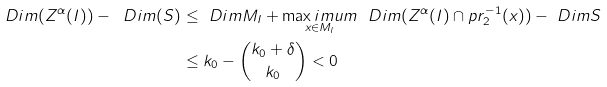<formula> <loc_0><loc_0><loc_500><loc_500>\ D i m ( Z ^ { \alpha } ( I ) ) - \ D i m ( S ) & \leq \ D i m M _ { I } + \underset { x \in M _ { I } } { \max i m u m } \ \ D i m ( Z ^ { \alpha } ( I ) \cap p r _ { 2 } ^ { - 1 } ( x ) ) - \ D i m S \\ & \leq k _ { 0 } - { k _ { 0 } + \delta \choose k _ { 0 } } < 0</formula> 